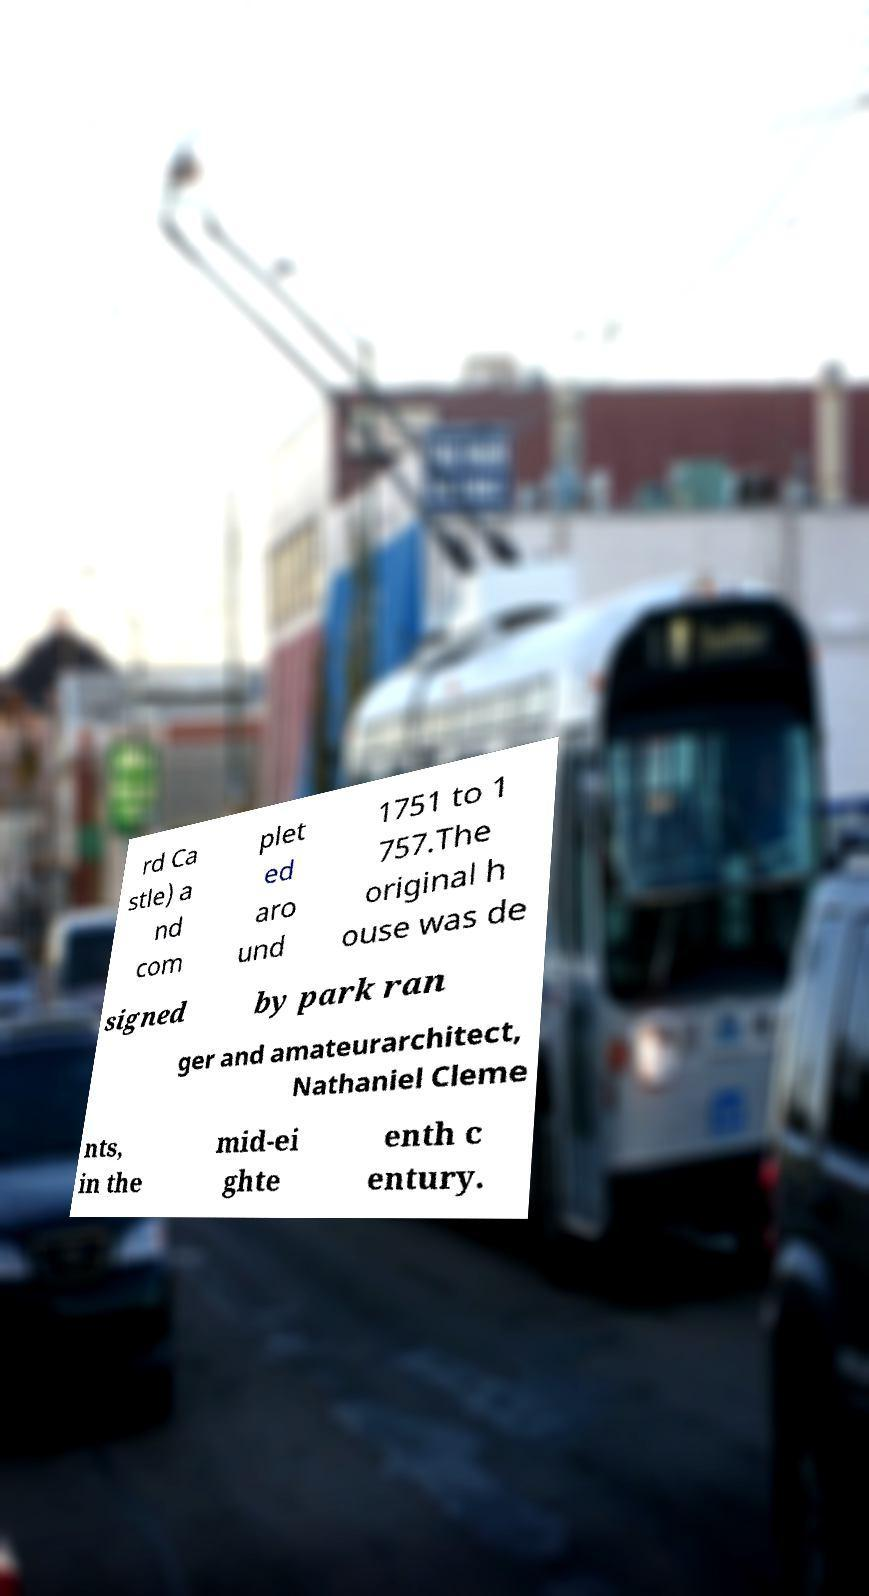Please identify and transcribe the text found in this image. rd Ca stle) a nd com plet ed aro und 1751 to 1 757.The original h ouse was de signed by park ran ger and amateurarchitect, Nathaniel Cleme nts, in the mid-ei ghte enth c entury. 